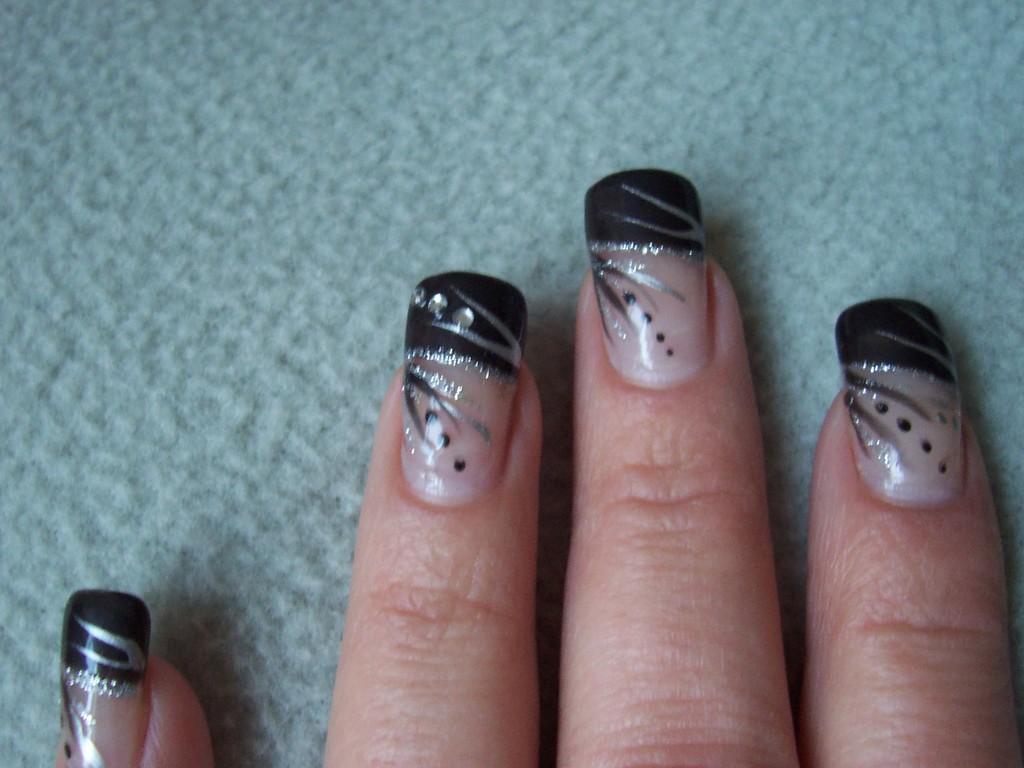How would you summarize this image in a sentence or two? In this picture we can see a person hand on a surface and on nails we can see nail polish. 